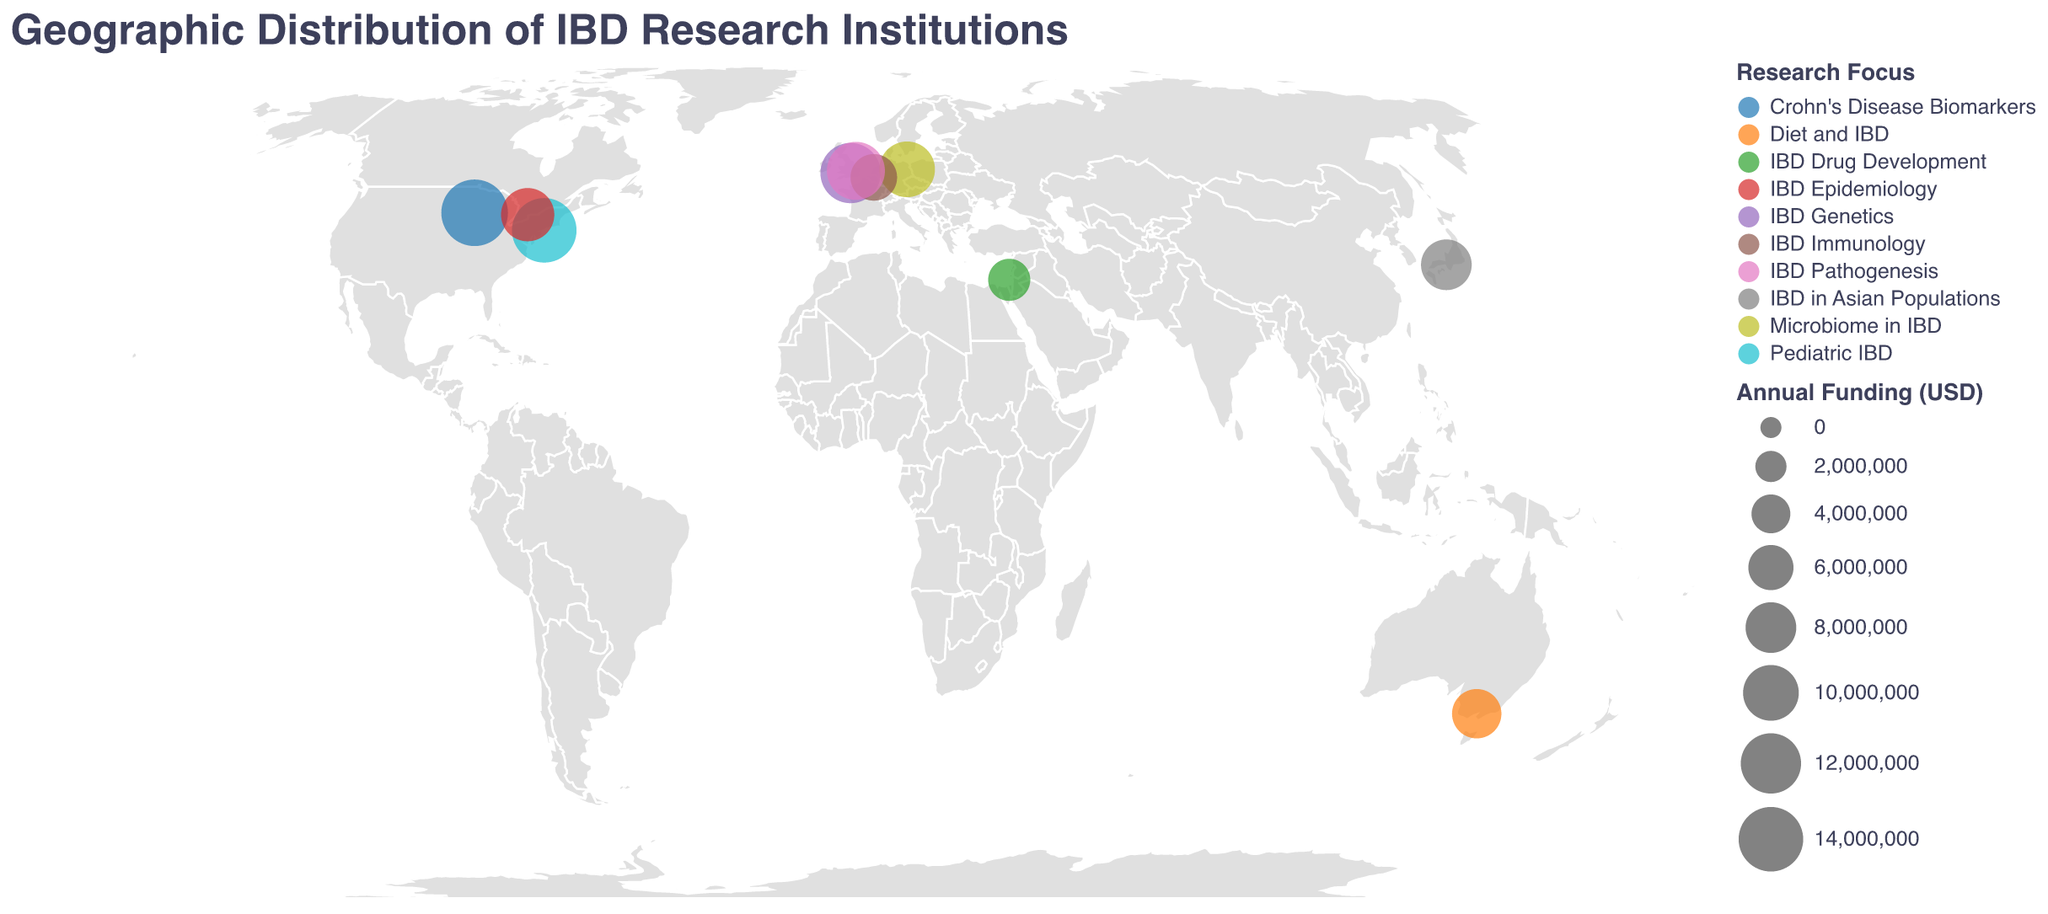What is the title of the figure? The title of the figure is displayed at the top of the visualization in a distinct font and color, indicating the main topic of the plot.
Answer: Geographic Distribution of IBD Research Institutions How many institutions are focused on IBD research according to the plot? Each institution is represented by a circle on the geographic map with associated data including location, funding, and research focus. Counting these circles gives the total number.
Answer: 10 Which institution receives the highest annual funding for IBD research? Each circle represents an institution, with size indicating the amount of funding. The largest circle signifies the highest funding. Based on the data provided, the Mayo Clinic has the largest circle.
Answer: Mayo Clinic What are the research focuses of institutions in the United Kingdom? The United Kingdom appears twice on the map, with circles denoting the University of Oxford and the University of Cambridge. The assigned color differentiates their research focuses, while the tooltip confirms them.
Answer: IBD Genetics and IBD Pathogenesis What is the total annual funding received by institutions in the USA? The USA has two institutions: the Mayo Clinic ($15,000,000) and the Icahn School of Medicine at Mount Sinai ($14,000,000). Adding these amounts provides the total funding.
Answer: $29,000,000 Which institution focuses on Microbiome in IBD, and where is it located? By identifying the research focus color coding and confirming through tooltips, we see that Charite - Universitatsmedizin Berlin focuses on Microbiome in IBD and is located in Berlin, Germany.
Answer: Charite - Universitatsmedizin Berlin, Berlin, Germany Compare the funding of the institutions in Oxford and Cambridge. Which one receives more annual funding? Both cities are in the UK and are represented on the map. Checking the circle sizes and tooltips shows that Cambridge ($11,000,000) receives less than Oxford ($12,000,000).
Answer: University of Oxford receives more funding What is the average funding for the institutions listed in the plot? Adding all the funding values (15000000 + 12000000 + 10000000 + 14000000 + 9000000 + 8000000 + 7500000 + 6500000 + 5000000 + 11000000) and dividing by the number of institutions (10) gives the average. The total funding is $98,000,000, so the average is $9,800,000.
Answer: $9,800,000 Which institution has the smallest annual funding, and how much is it? The smallest circle size indicates the lowest funded institution. Tel Aviv University has the smallest circle, and a tooltip confirms it receives $5,000,000.
Answer: Tel Aviv University, $5,000,000 Is there any institution in Australia focusing on IBD research? If so, what is its research focus and funding? The map shows a circle in Australia, and the tooltip reveals that the University of Melbourne focuses on Diet and IBD, with funding of $7,500,000.
Answer: University of Melbourne, Diet and IBD, $7,500,000 